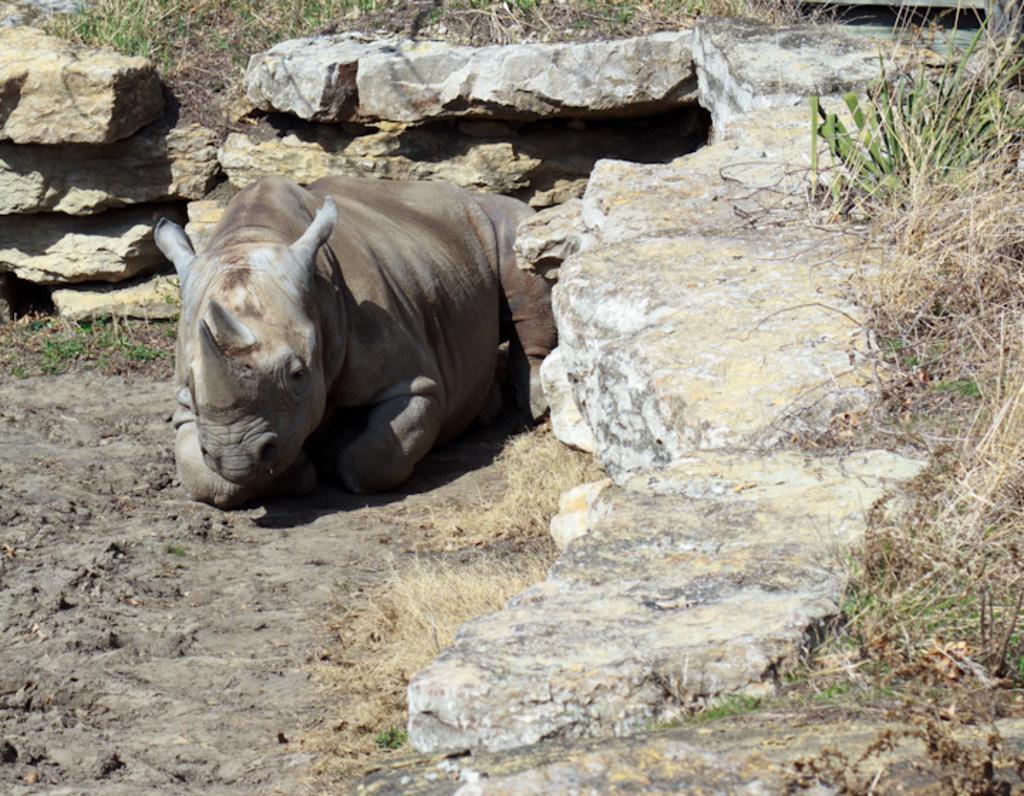How would you summarize this image in a sentence or two? In this image we can see an animal sitting on the ground and there are some rocks and we can see the grass. 